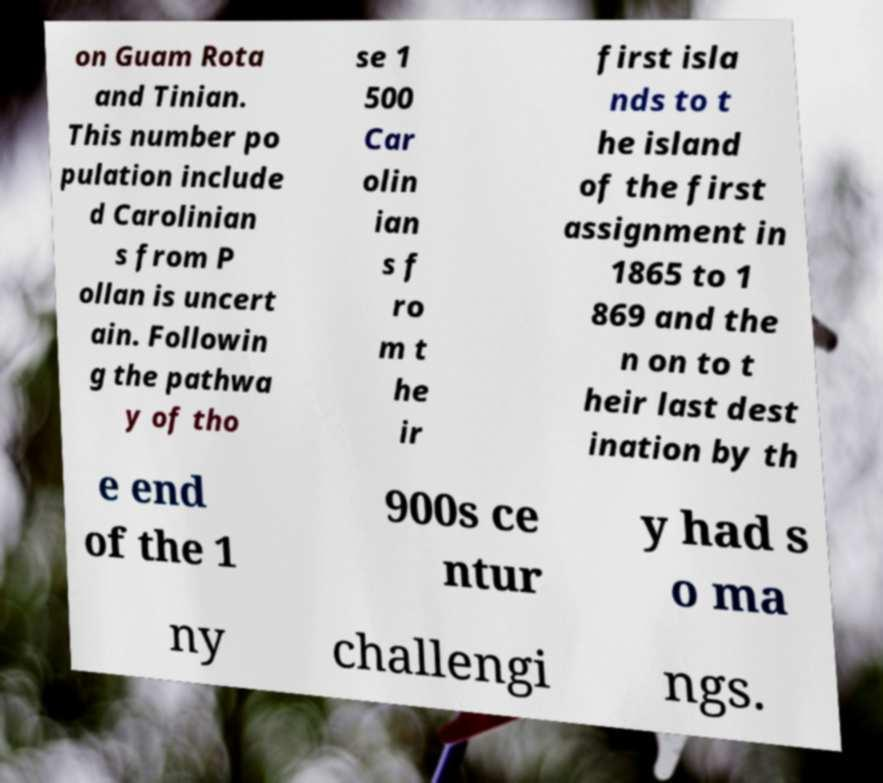Could you extract and type out the text from this image? on Guam Rota and Tinian. This number po pulation include d Carolinian s from P ollan is uncert ain. Followin g the pathwa y of tho se 1 500 Car olin ian s f ro m t he ir first isla nds to t he island of the first assignment in 1865 to 1 869 and the n on to t heir last dest ination by th e end of the 1 900s ce ntur y had s o ma ny challengi ngs. 